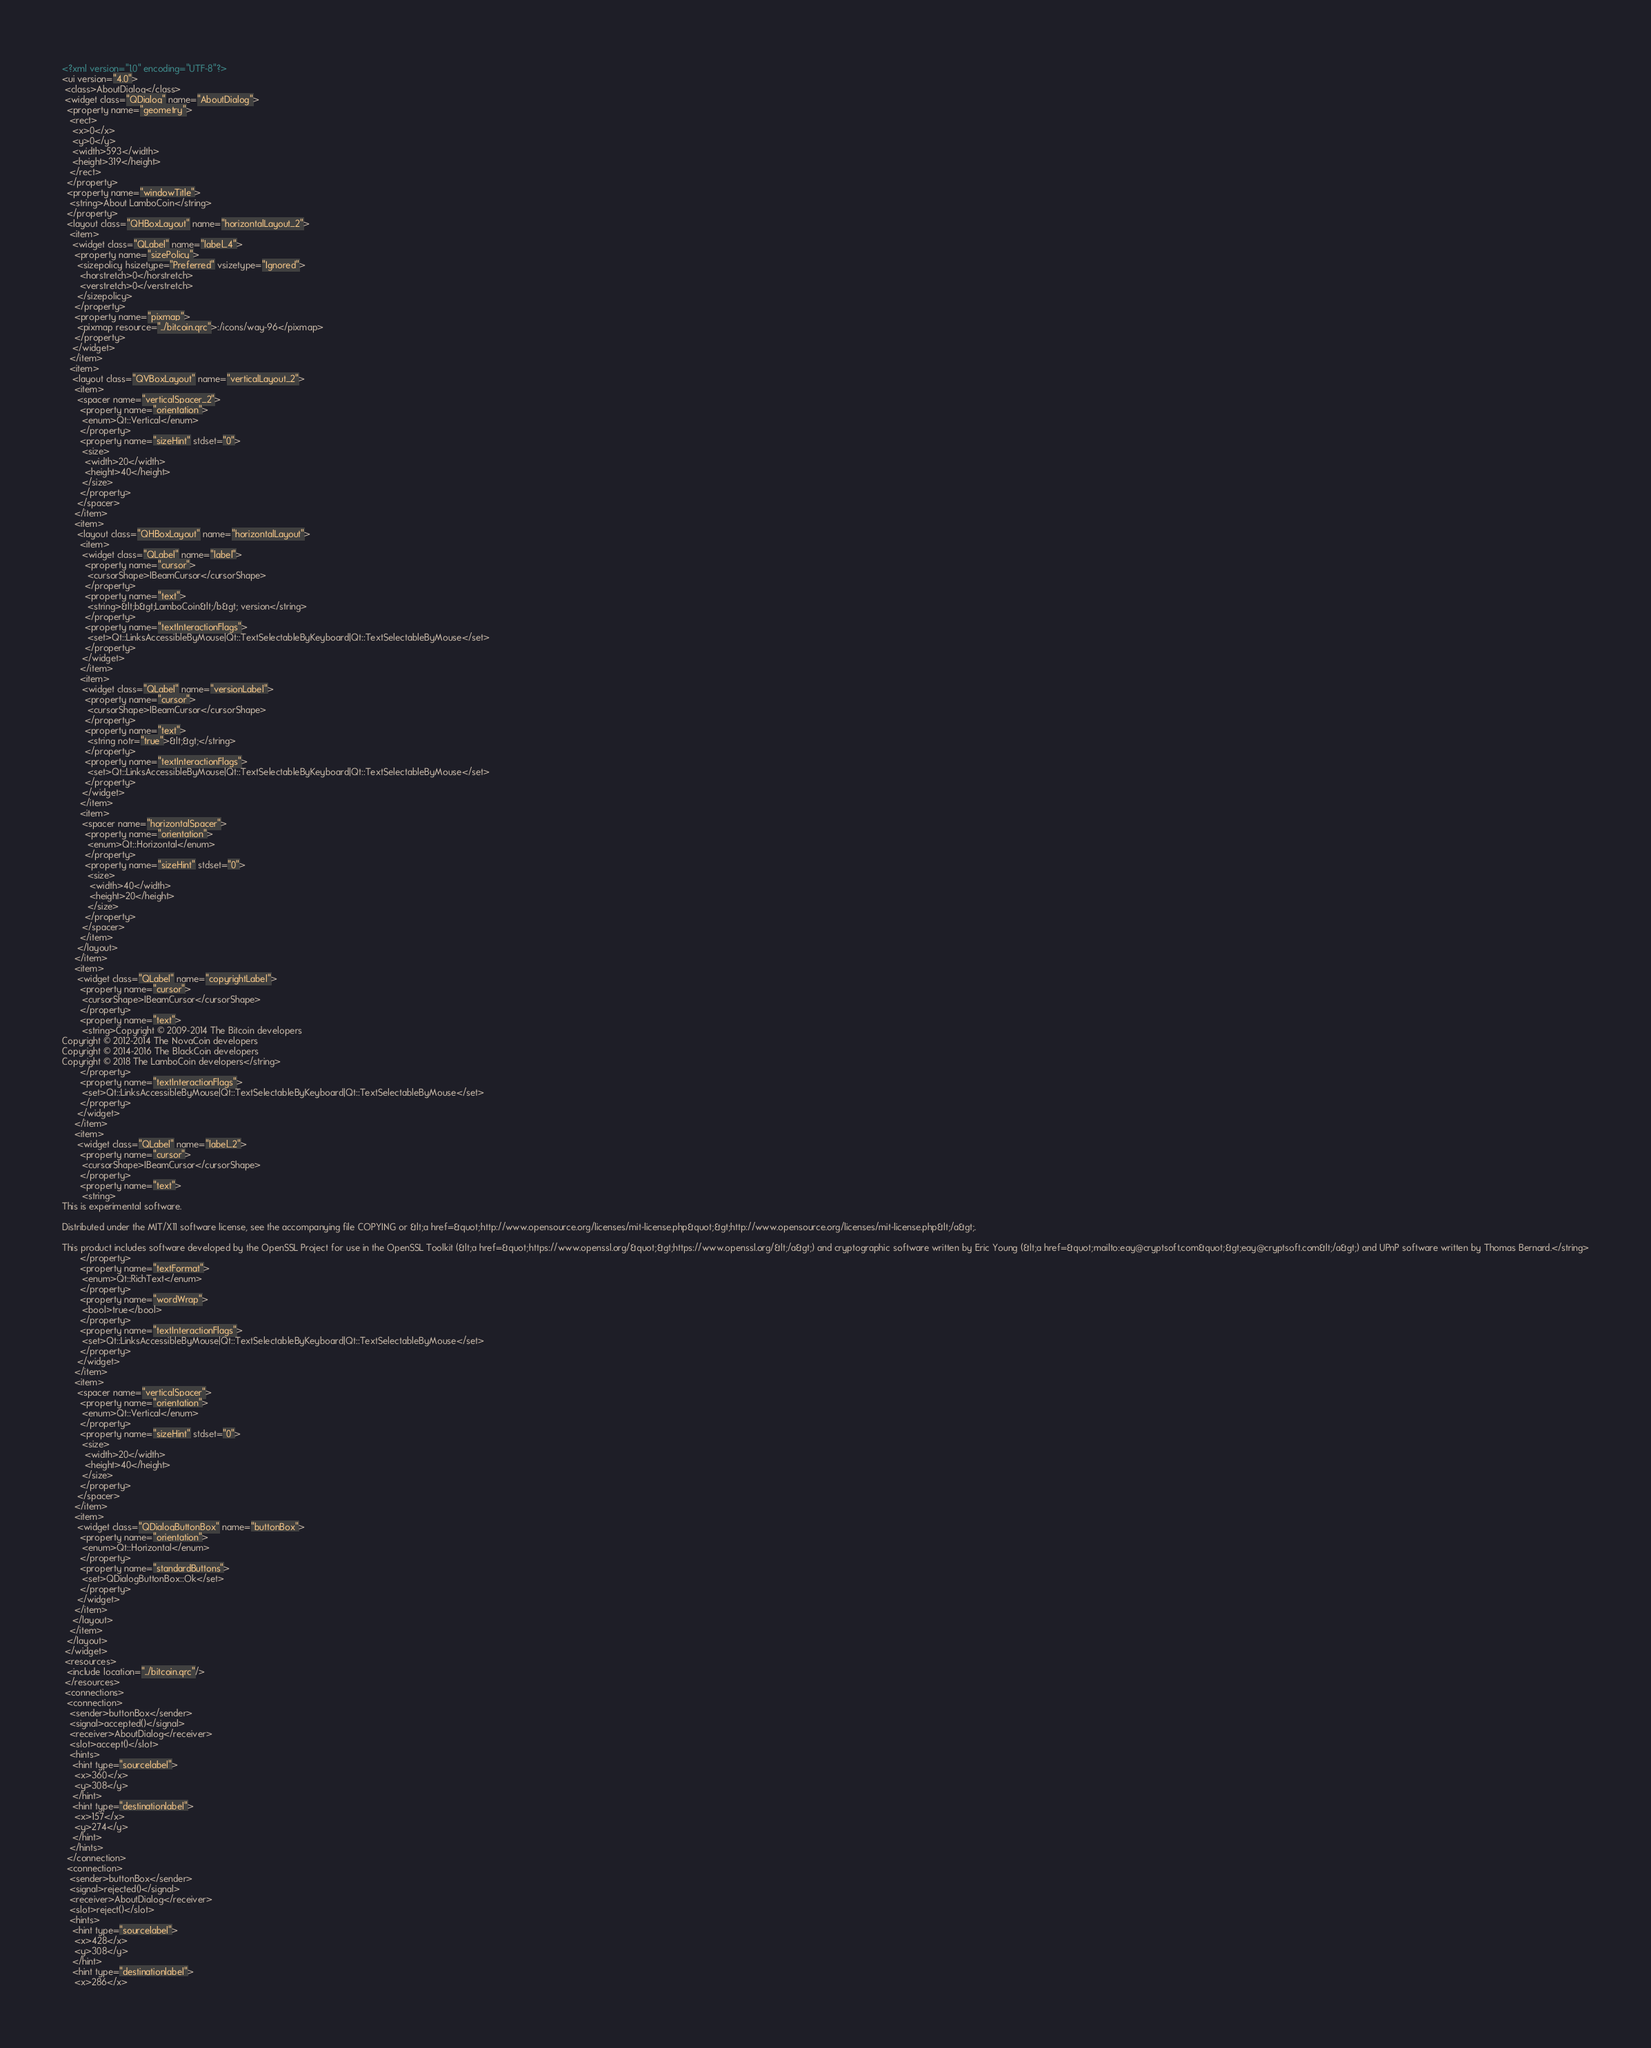<code> <loc_0><loc_0><loc_500><loc_500><_XML_><?xml version="1.0" encoding="UTF-8"?>
<ui version="4.0">
 <class>AboutDialog</class>
 <widget class="QDialog" name="AboutDialog">
  <property name="geometry">
   <rect>
    <x>0</x>
    <y>0</y>
    <width>593</width>
    <height>319</height>
   </rect>
  </property>
  <property name="windowTitle">
   <string>About LamboCoin</string>
  </property>
  <layout class="QHBoxLayout" name="horizontalLayout_2">
   <item>
    <widget class="QLabel" name="label_4">
     <property name="sizePolicy">
      <sizepolicy hsizetype="Preferred" vsizetype="Ignored">
       <horstretch>0</horstretch>
       <verstretch>0</verstretch>
      </sizepolicy>
     </property>
     <property name="pixmap">
      <pixmap resource="../bitcoin.qrc">:/icons/way-96</pixmap>
     </property>
    </widget>
   </item>
   <item>
    <layout class="QVBoxLayout" name="verticalLayout_2">
     <item>
      <spacer name="verticalSpacer_2">
       <property name="orientation">
        <enum>Qt::Vertical</enum>
       </property>
       <property name="sizeHint" stdset="0">
        <size>
         <width>20</width>
         <height>40</height>
        </size>
       </property>
      </spacer>
     </item>
     <item>
      <layout class="QHBoxLayout" name="horizontalLayout">
       <item>
        <widget class="QLabel" name="label">
         <property name="cursor">
          <cursorShape>IBeamCursor</cursorShape>
         </property>
         <property name="text">
          <string>&lt;b&gt;LamboCoin&lt;/b&gt; version</string>
         </property>
         <property name="textInteractionFlags">
          <set>Qt::LinksAccessibleByMouse|Qt::TextSelectableByKeyboard|Qt::TextSelectableByMouse</set>
         </property>
        </widget>
       </item>
       <item>
        <widget class="QLabel" name="versionLabel">
         <property name="cursor">
          <cursorShape>IBeamCursor</cursorShape>
         </property>
         <property name="text">
          <string notr="true">&lt;&gt;</string>
         </property>
         <property name="textInteractionFlags">
          <set>Qt::LinksAccessibleByMouse|Qt::TextSelectableByKeyboard|Qt::TextSelectableByMouse</set>
         </property>
        </widget>
       </item>
       <item>
        <spacer name="horizontalSpacer">
         <property name="orientation">
          <enum>Qt::Horizontal</enum>
         </property>
         <property name="sizeHint" stdset="0">
          <size>
           <width>40</width>
           <height>20</height>
          </size>
         </property>
        </spacer>
       </item>
      </layout>
     </item>
     <item>
      <widget class="QLabel" name="copyrightLabel">
       <property name="cursor">
        <cursorShape>IBeamCursor</cursorShape>
       </property>
       <property name="text">
        <string>Copyright © 2009-2014 The Bitcoin developers
Copyright © 2012-2014 The NovaCoin developers
Copyright © 2014-2016 The BlackCoin developers
Copyright © 2018 The LamboCoin developers</string>
       </property>
       <property name="textInteractionFlags">
        <set>Qt::LinksAccessibleByMouse|Qt::TextSelectableByKeyboard|Qt::TextSelectableByMouse</set>
       </property>
      </widget>
     </item>
     <item>
      <widget class="QLabel" name="label_2">
       <property name="cursor">
        <cursorShape>IBeamCursor</cursorShape>
       </property>
       <property name="text">
        <string>
This is experimental software.

Distributed under the MIT/X11 software license, see the accompanying file COPYING or &lt;a href=&quot;http://www.opensource.org/licenses/mit-license.php&quot;&gt;http://www.opensource.org/licenses/mit-license.php&lt;/a&gt;.

This product includes software developed by the OpenSSL Project for use in the OpenSSL Toolkit (&lt;a href=&quot;https://www.openssl.org/&quot;&gt;https://www.openssl.org/&lt;/a&gt;) and cryptographic software written by Eric Young (&lt;a href=&quot;mailto:eay@cryptsoft.com&quot;&gt;eay@cryptsoft.com&lt;/a&gt;) and UPnP software written by Thomas Bernard.</string>
       </property>
       <property name="textFormat">
        <enum>Qt::RichText</enum>
       </property>
       <property name="wordWrap">
        <bool>true</bool>
       </property>
       <property name="textInteractionFlags">
        <set>Qt::LinksAccessibleByMouse|Qt::TextSelectableByKeyboard|Qt::TextSelectableByMouse</set>
       </property>
      </widget>
     </item>
     <item>
      <spacer name="verticalSpacer">
       <property name="orientation">
        <enum>Qt::Vertical</enum>
       </property>
       <property name="sizeHint" stdset="0">
        <size>
         <width>20</width>
         <height>40</height>
        </size>
       </property>
      </spacer>
     </item>
     <item>
      <widget class="QDialogButtonBox" name="buttonBox">
       <property name="orientation">
        <enum>Qt::Horizontal</enum>
       </property>
       <property name="standardButtons">
        <set>QDialogButtonBox::Ok</set>
       </property>
      </widget>
     </item>
    </layout>
   </item>
  </layout>
 </widget>
 <resources>
  <include location="../bitcoin.qrc"/>
 </resources>
 <connections>
  <connection>
   <sender>buttonBox</sender>
   <signal>accepted()</signal>
   <receiver>AboutDialog</receiver>
   <slot>accept()</slot>
   <hints>
    <hint type="sourcelabel">
     <x>360</x>
     <y>308</y>
    </hint>
    <hint type="destinationlabel">
     <x>157</x>
     <y>274</y>
    </hint>
   </hints>
  </connection>
  <connection>
   <sender>buttonBox</sender>
   <signal>rejected()</signal>
   <receiver>AboutDialog</receiver>
   <slot>reject()</slot>
   <hints>
    <hint type="sourcelabel">
     <x>428</x>
     <y>308</y>
    </hint>
    <hint type="destinationlabel">
     <x>286</x></code> 